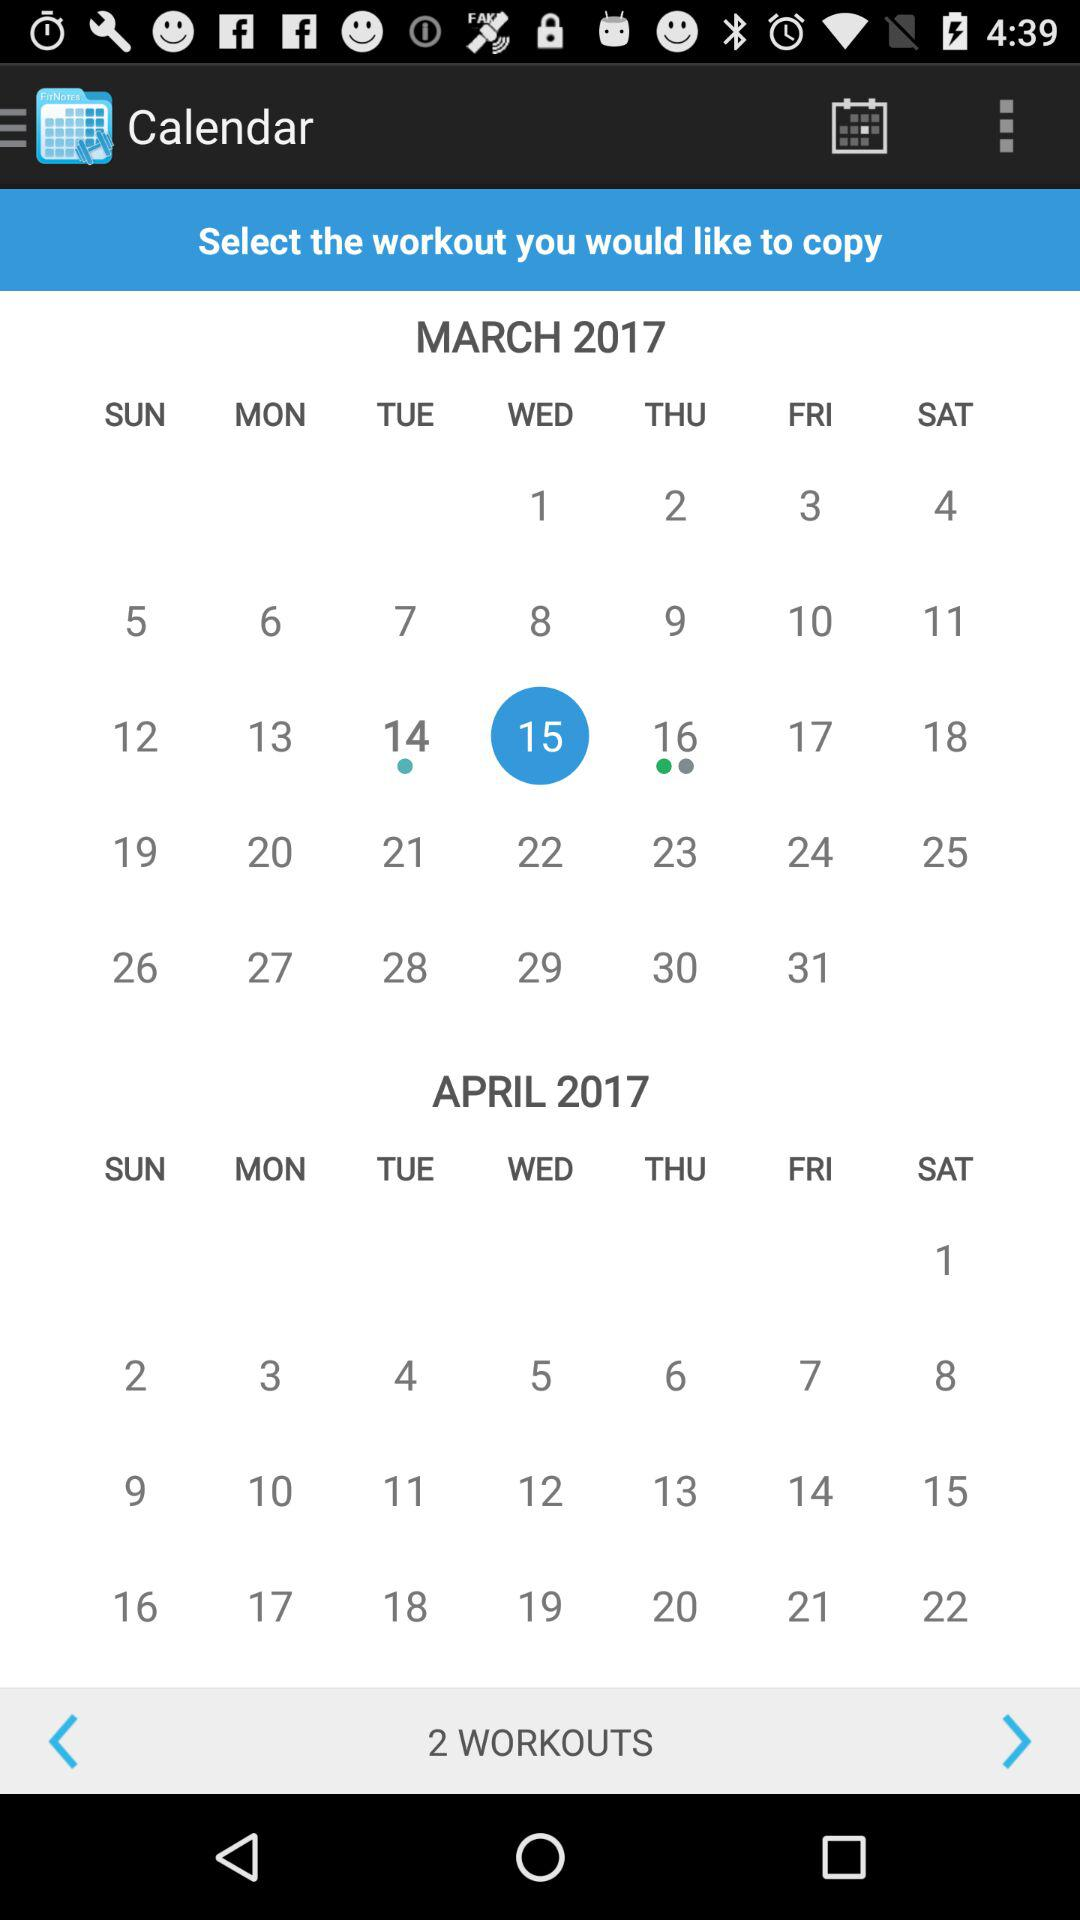Which year is shown on the calendar? The year shown on the calendar is 2017. 